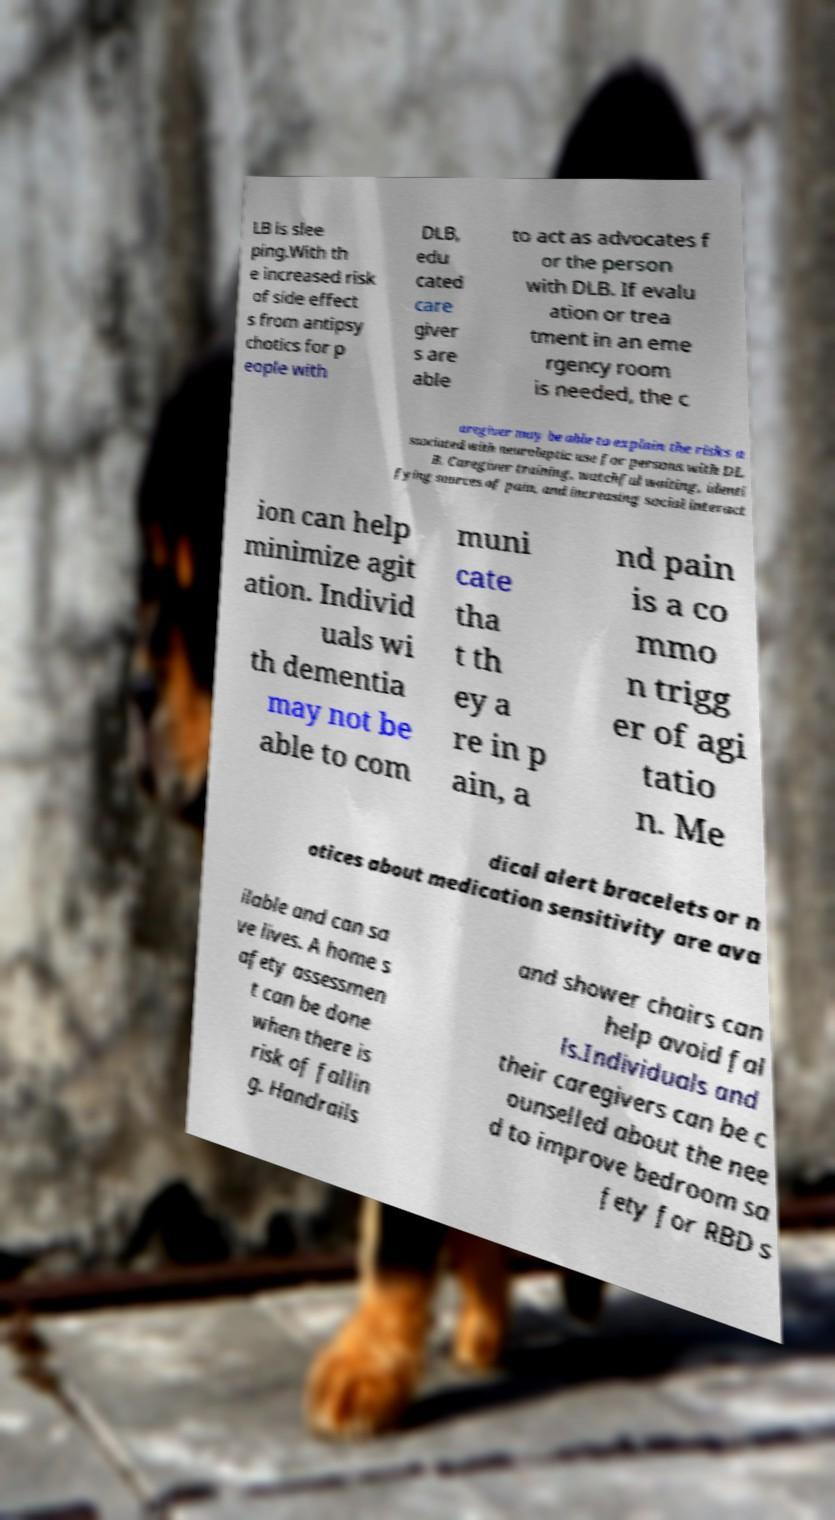Please identify and transcribe the text found in this image. LB is slee ping.With th e increased risk of side effect s from antipsy chotics for p eople with DLB, edu cated care giver s are able to act as advocates f or the person with DLB. If evalu ation or trea tment in an eme rgency room is needed, the c aregiver may be able to explain the risks a ssociated with neuroleptic use for persons with DL B. Caregiver training, watchful waiting, identi fying sources of pain, and increasing social interact ion can help minimize agit ation. Individ uals wi th dementia may not be able to com muni cate tha t th ey a re in p ain, a nd pain is a co mmo n trigg er of agi tatio n. Me dical alert bracelets or n otices about medication sensitivity are ava ilable and can sa ve lives. A home s afety assessmen t can be done when there is risk of fallin g. Handrails and shower chairs can help avoid fal ls.Individuals and their caregivers can be c ounselled about the nee d to improve bedroom sa fety for RBD s 